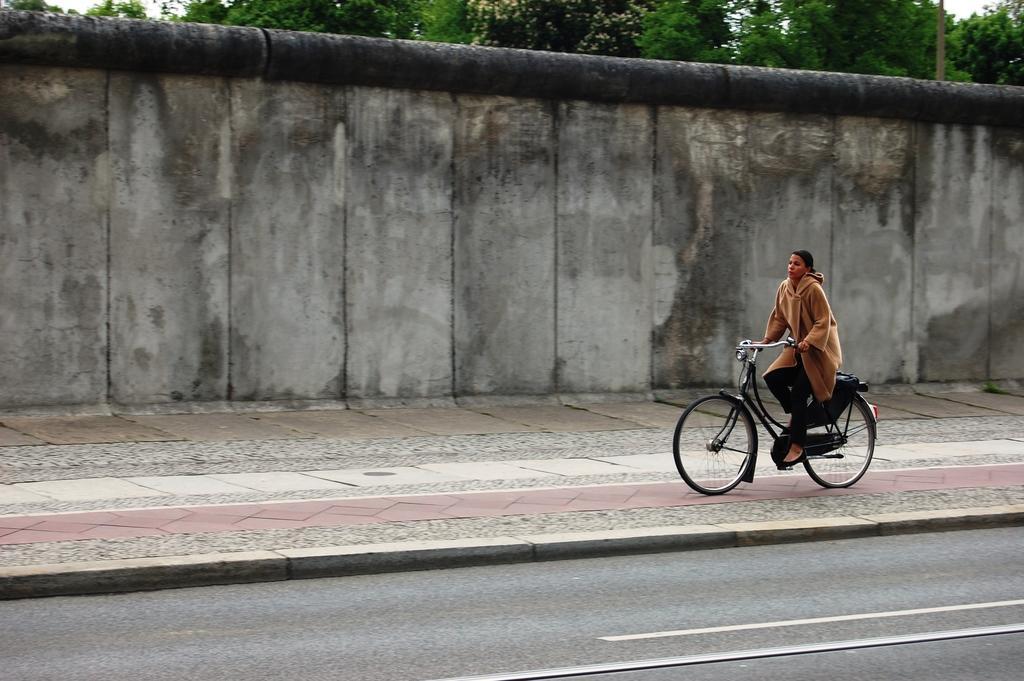Please provide a concise description of this image. Here we can see a man is riding on the bicycle, and here is the road, and here is the wall, and at back here is the tree. 